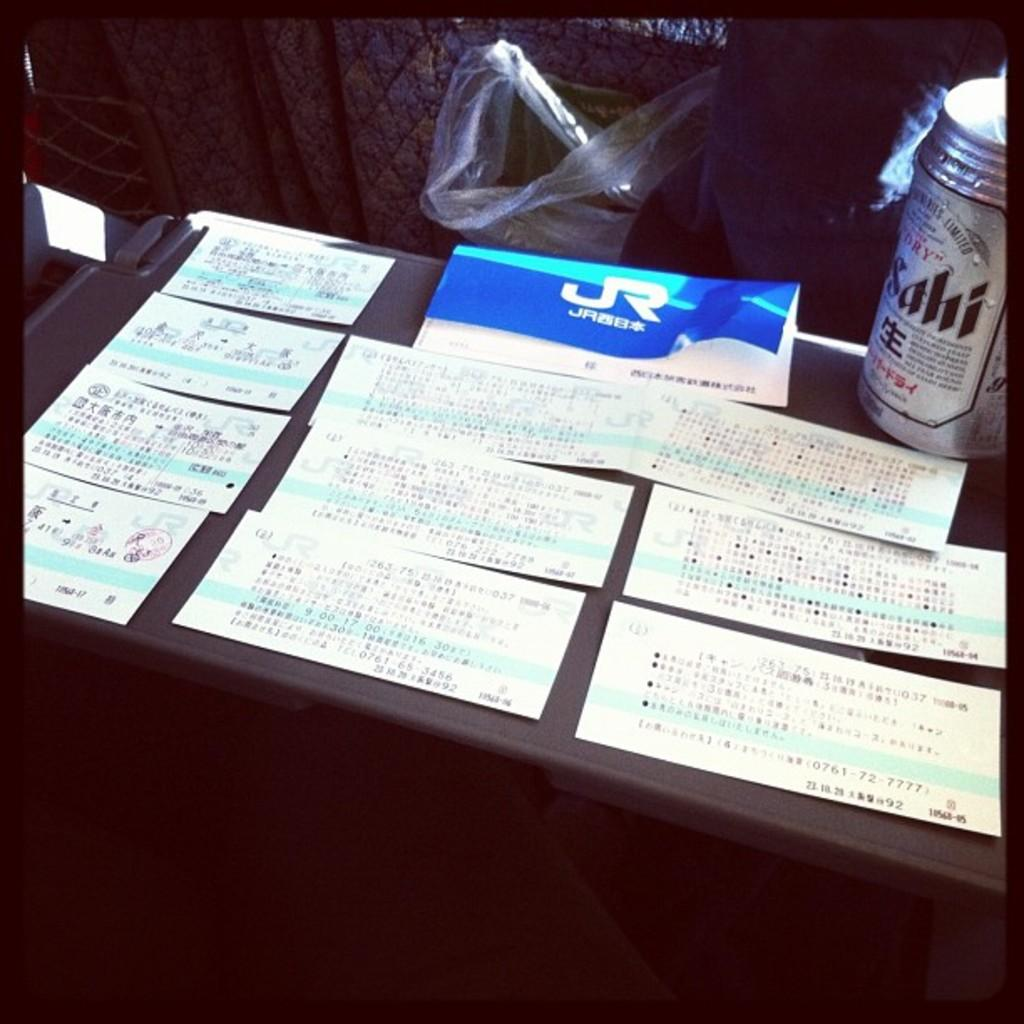<image>
Give a short and clear explanation of the subsequent image. Assorted note cards with writing sprawled out on a desk with a beverage in a can called sahi. 